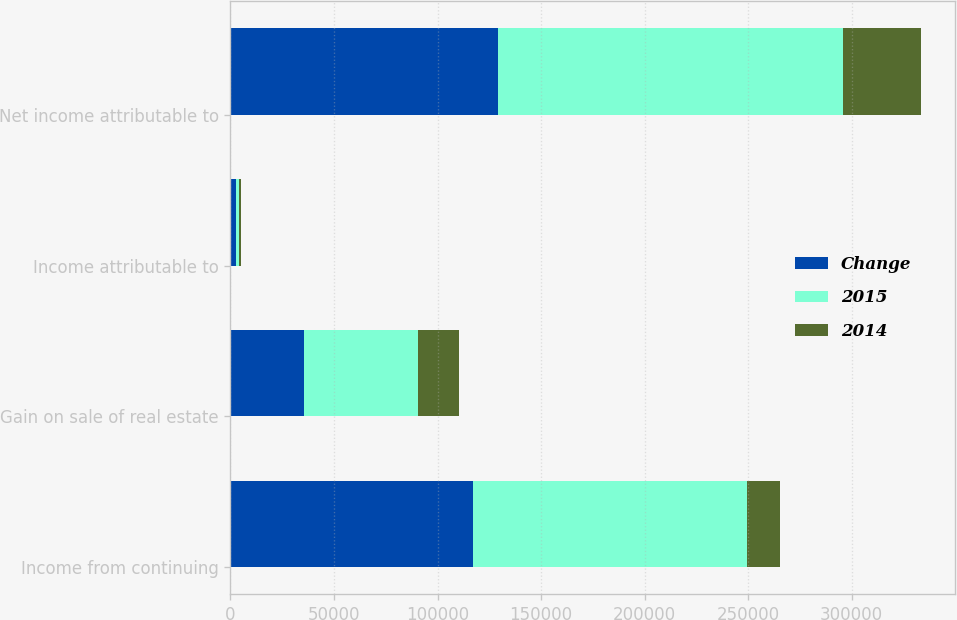<chart> <loc_0><loc_0><loc_500><loc_500><stacked_bar_chart><ecel><fcel>Income from continuing<fcel>Gain on sale of real estate<fcel>Income attributable to<fcel>Net income attributable to<nl><fcel>Change<fcel>116937<fcel>35606<fcel>2487<fcel>129234<nl><fcel>2015<fcel>132774<fcel>55077<fcel>1457<fcel>166647<nl><fcel>2014<fcel>15837<fcel>19471<fcel>1030<fcel>37413<nl></chart> 